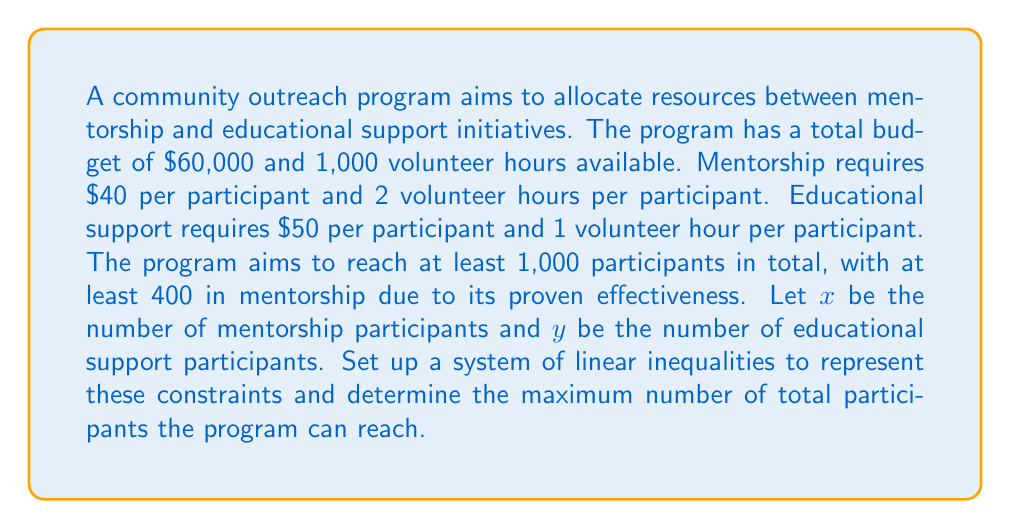Can you solve this math problem? Let's break this problem down step-by-step:

1) First, we need to set up our constraints based on the given information:

   a) Budget constraint: 
      $40x + 50y \leq 60000$

   b) Volunteer hours constraint:
      $2x + y \leq 1000$

   c) Minimum total participants:
      $x + y \geq 1000$

   d) Minimum mentorship participants:
      $x \geq 400$

   e) Non-negativity constraints:
      $x \geq 0$, $y \geq 0$

2) Our objective is to maximize the total number of participants, which is represented by $x + y$.

3) To solve this system of linear inequalities, we can use the graphical method or linear programming techniques. However, we can also reason through it:

   - We know $x$ must be at least 400.
   - Given the budget and volunteer hour constraints, we can't maximize both $x$ and $y$ simultaneously.
   - The most efficient use of resources in terms of maximizing participants is to set $x$ to its minimum (400) and then maximize $y$.

4) Let's substitute $x = 400$ into our constraints:

   Budget: $40(400) + 50y \leq 60000$
           $16000 + 50y \leq 60000$
           $50y \leq 44000$
           $y \leq 880$

   Volunteer hours: $2(400) + y \leq 1000$
                    $800 + y \leq 1000$
                    $y \leq 200$

5) The binding constraint is the volunteer hours, limiting $y$ to 200.

6) Therefore, the maximum number of participants is:
   $x + y = 400 + 200 = 600$
Answer: The maximum number of total participants the program can reach is 600, with 400 in mentorship and 200 in educational support. 